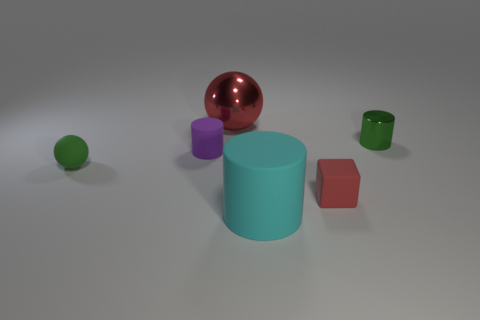Add 3 tiny blocks. How many objects exist? 9 Subtract all balls. How many objects are left? 4 Add 4 small cubes. How many small cubes are left? 5 Add 2 large cylinders. How many large cylinders exist? 3 Subtract 0 blue spheres. How many objects are left? 6 Subtract all tiny green cubes. Subtract all green shiny cylinders. How many objects are left? 5 